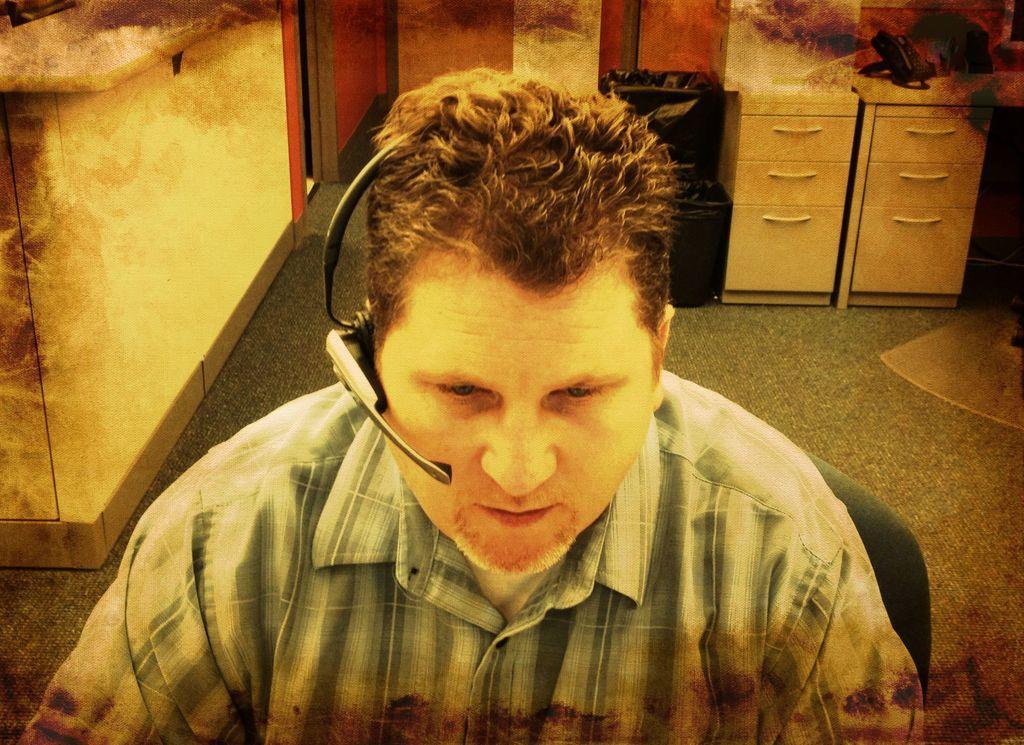Please provide a concise description of this image. In this image I can see a person sitting and the person is wearing white and gray color shirt, background I can see few cupboards in white color and the wall is in white and brown color. 